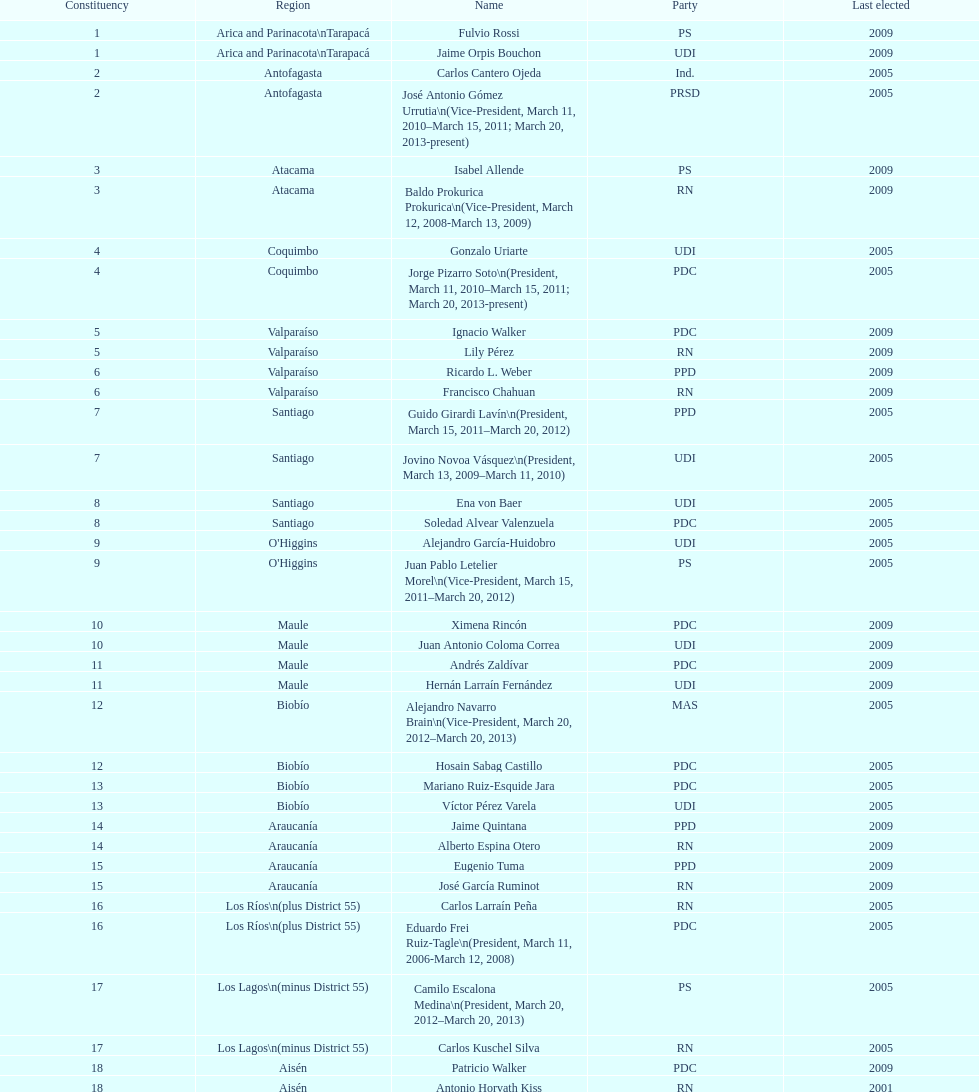When was antonio horvath kiss last elected? 2001. 